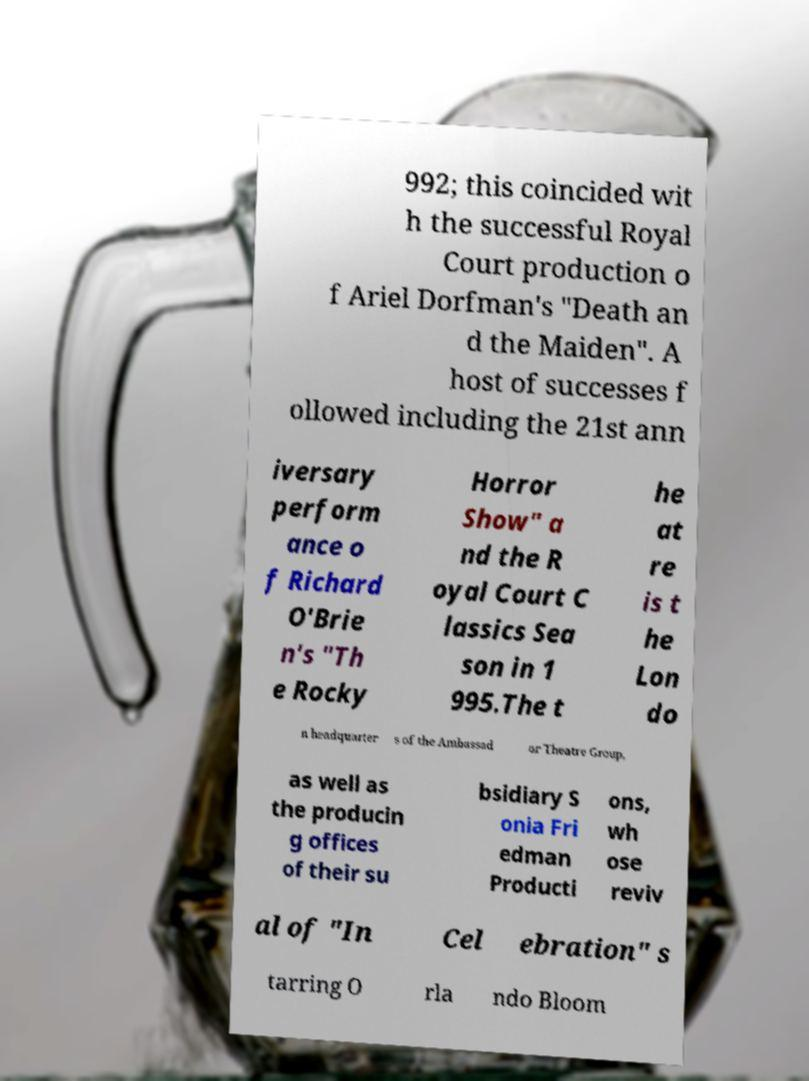Please read and relay the text visible in this image. What does it say? 992; this coincided wit h the successful Royal Court production o f Ariel Dorfman's "Death an d the Maiden". A host of successes f ollowed including the 21st ann iversary perform ance o f Richard O'Brie n's "Th e Rocky Horror Show" a nd the R oyal Court C lassics Sea son in 1 995.The t he at re is t he Lon do n headquarter s of the Ambassad or Theatre Group, as well as the producin g offices of their su bsidiary S onia Fri edman Producti ons, wh ose reviv al of "In Cel ebration" s tarring O rla ndo Bloom 